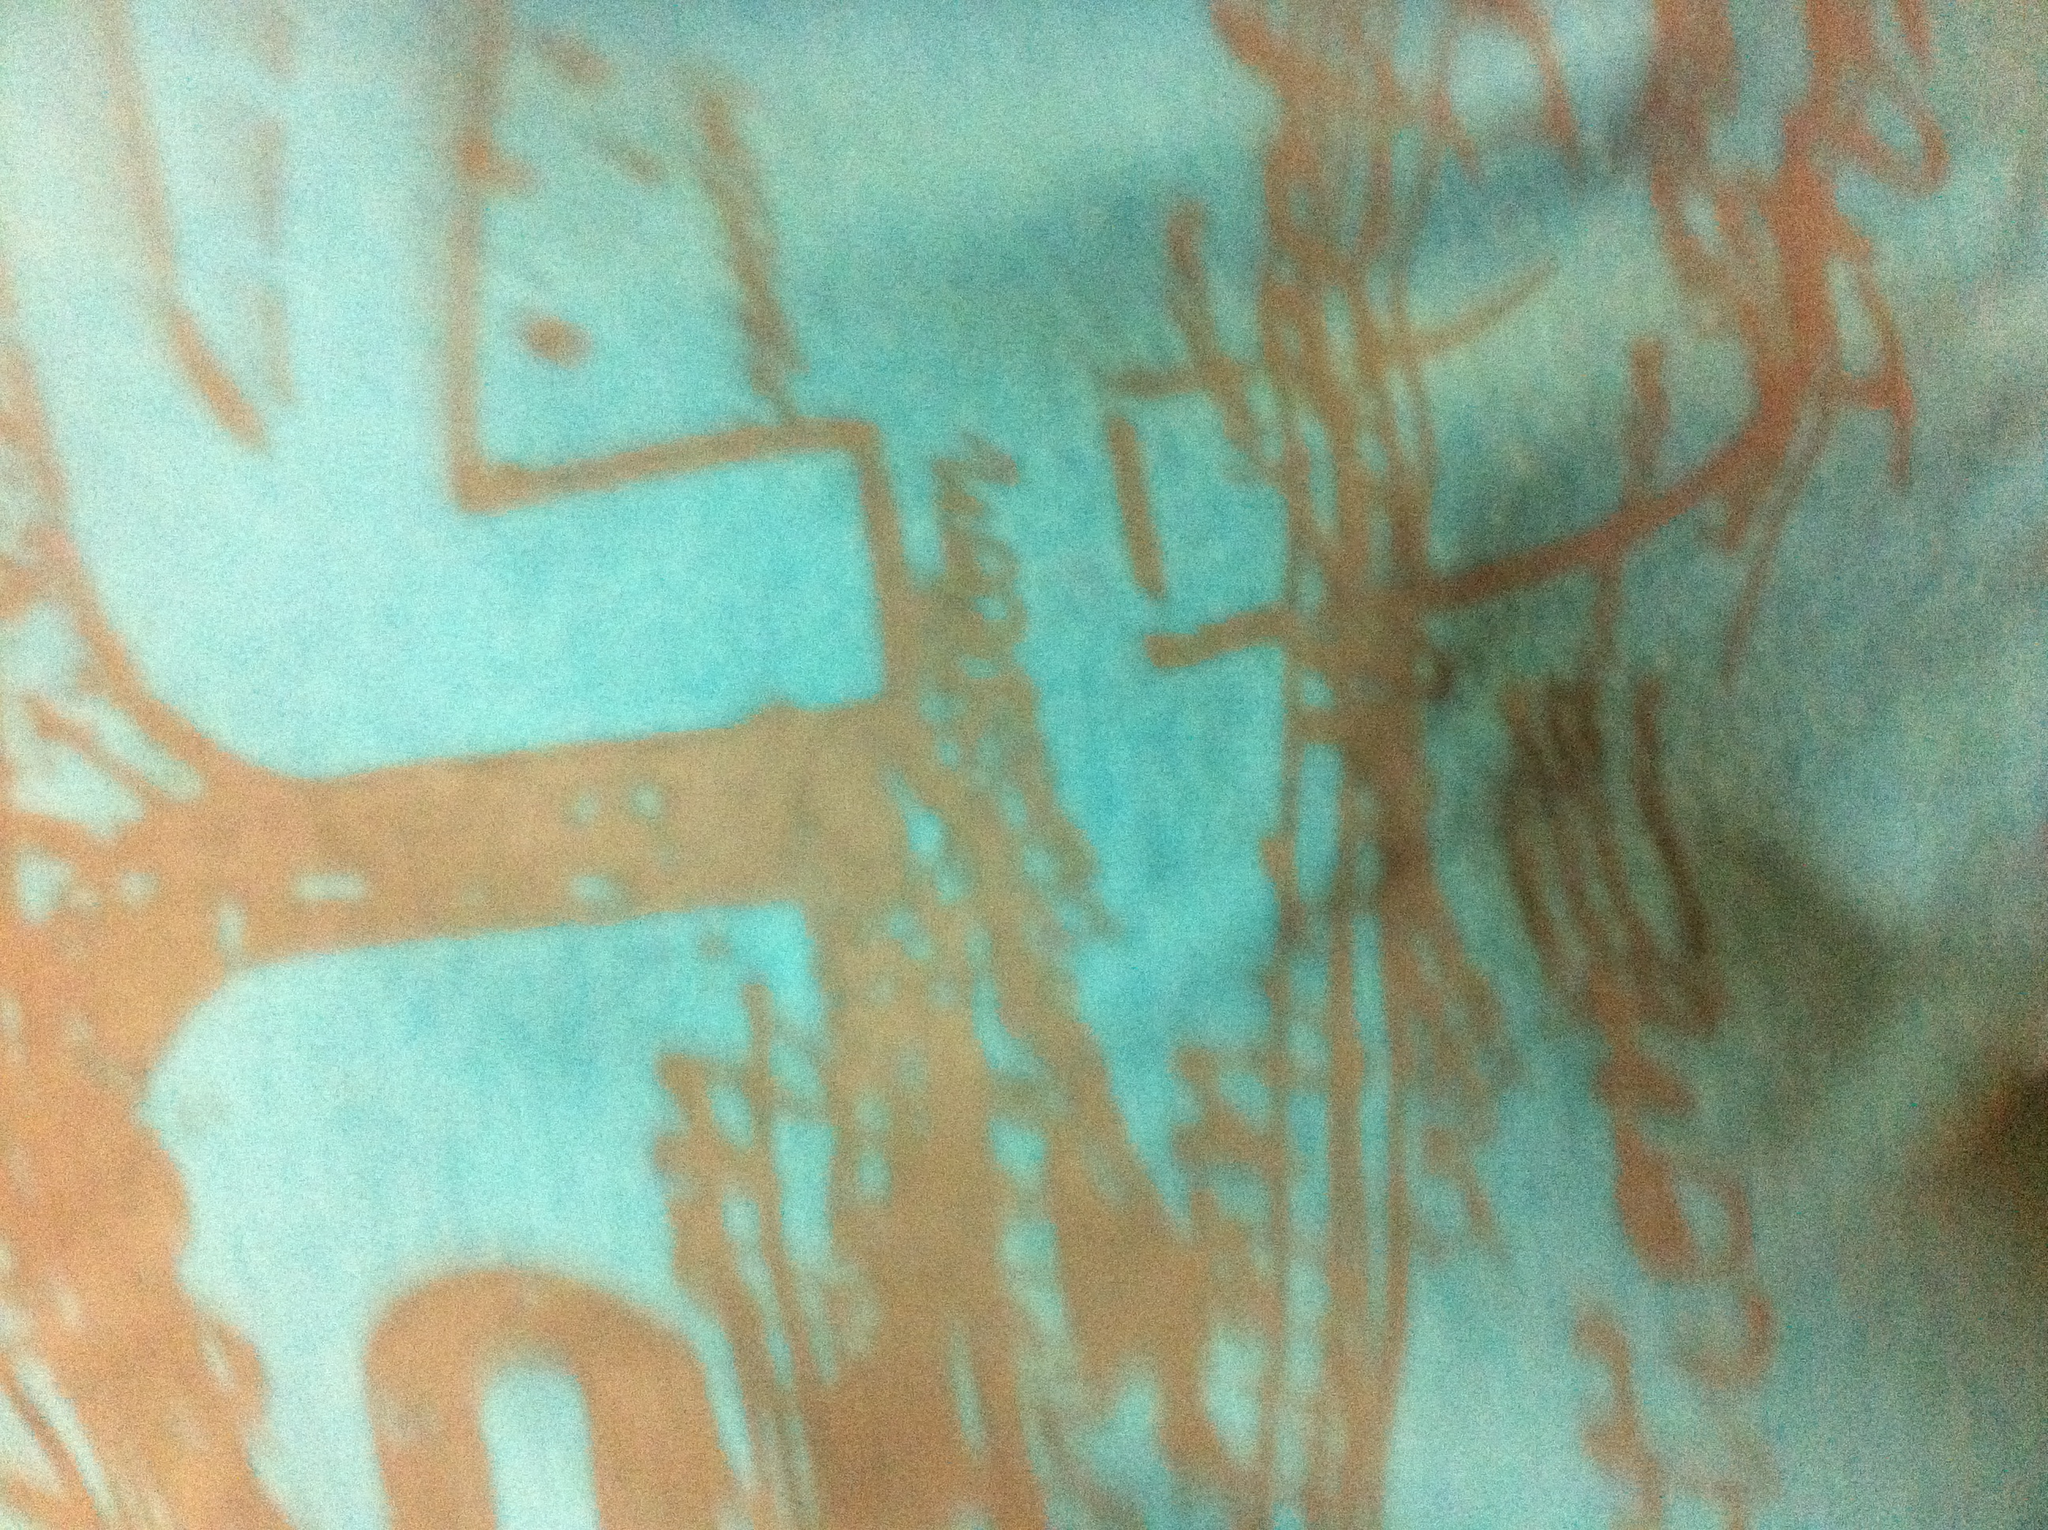What season is this shirt suitable for? This shirt, with its light and airy material, appears suitable for warmer seasons like spring or summer. The bright colors and patterns also suggest it's designed for casual, outdoor or sunny days. Can you imagine a scenario where this shirt would stand out exceptionally well? Imagine wearing this shirt at a vibrant summer festival, where the colors reflect the lively atmosphere. With its bold design, you’d stand out among the crowd, merging perfectly with the music, the laughter, and the endless sunshine. If this shirt could tell a story, what would it be? Long ago, in a quaint coastal town, an artist found solace in the rhythms of the ocean waves. Inspired by the interplay of rust on shipwrecks and the serene blues of the sea, they created a piece of art that captured the very essence of their musings. This shirt, adorned with abstract patterns, represents that artistic journey—a fusion of nature's raw beauty and human creativity. Each brushstroke on the fabric sings tales of sunsets on the beach, lazy days under the palm trees, and the timeless dance of the waves on the shore. 